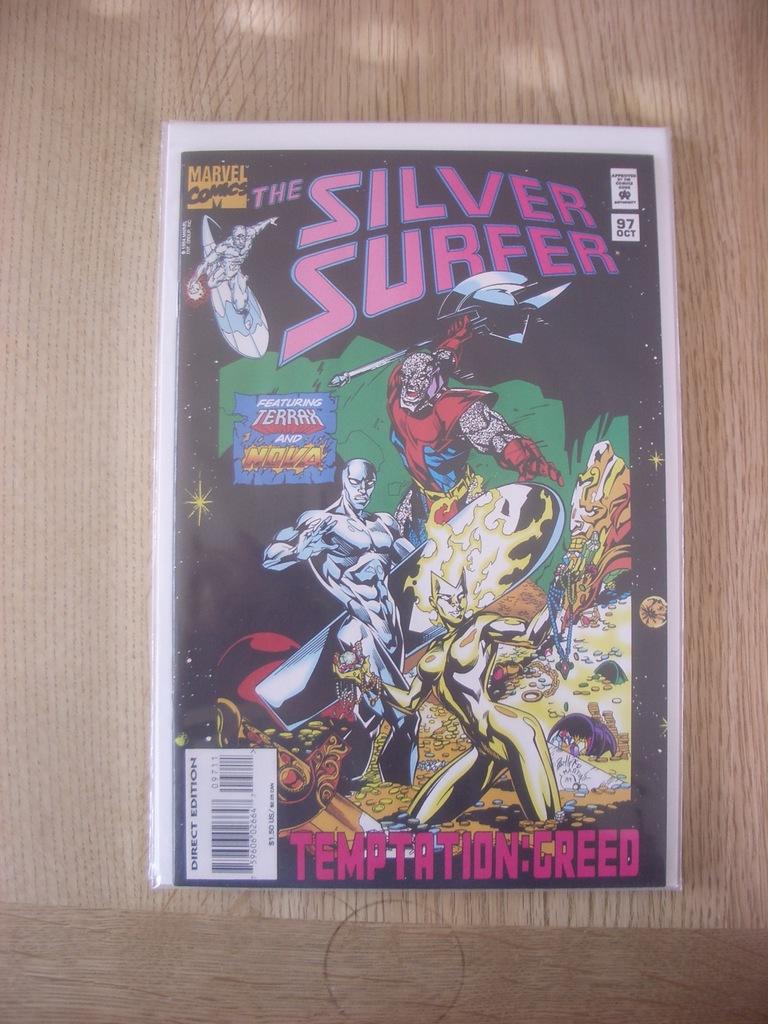What is the title of this comic?
Make the answer very short. The silver surfer. 